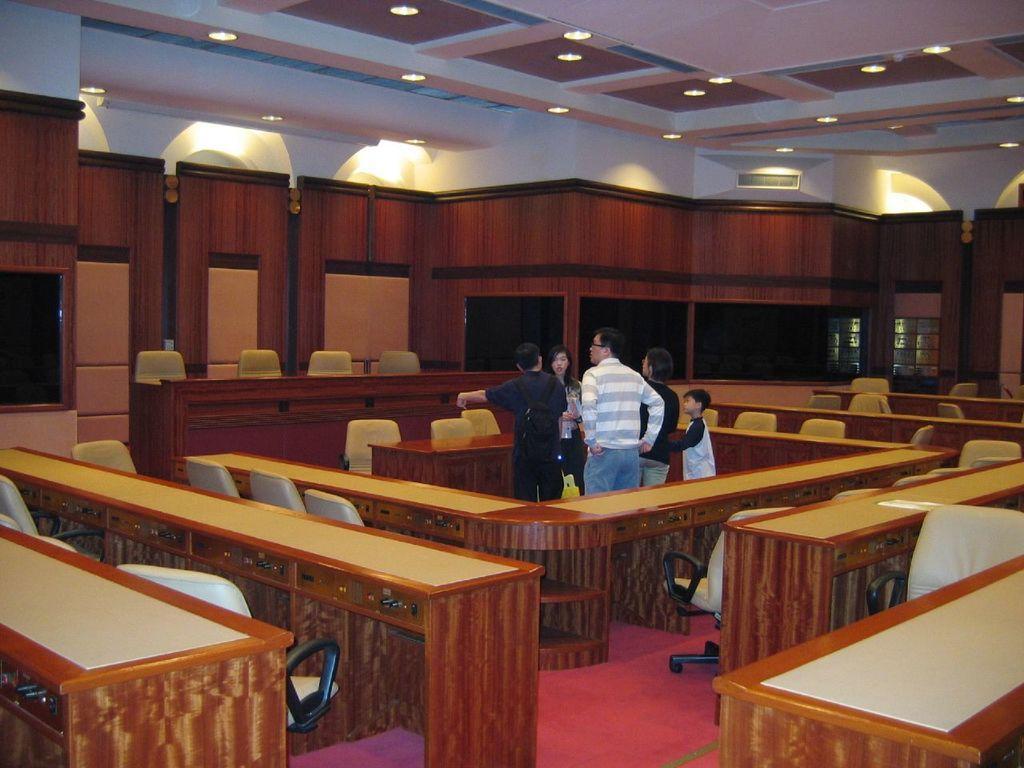Describe this image in one or two sentences. In this image i can see few people standing in the middle of the conference hall. I can see few chairs in front of few desks. In the background i can see the wall, the ceiling, the ac vent and few lights. 